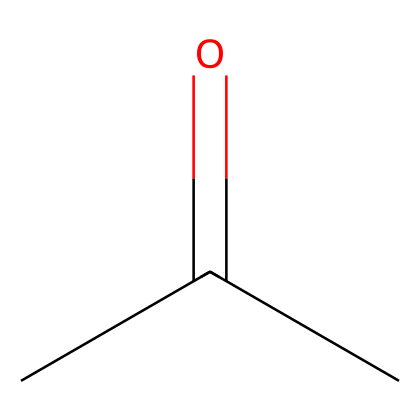What is the molecular formula of this compound? The SMILES notation CC(=O)C indicates that there are three carbon atoms, six hydrogen atoms, and one oxygen atom in the molecule, leading to the molecular formula C3H6O.
Answer: C3H6O How many carbon atoms are present in this molecule? Looking at the SMILES representation, there are three occurrences of 'C', indicating that there are three carbon atoms present in the structure.
Answer: 3 What type of functional group is present in this compound? The "=O" part in the SMILES indicates the presence of a carbonyl group, and since it's attached to a carbon (C) indicated by "CC(=O)", this is characteristic of a ketone.
Answer: ketone What is one common use of acetone? Acetone is commonly used as a solvent in various industrial applications, particularly for cleaning electronic components due to its ability to dissolve many substances.
Answer: solvent How many hydrogen atoms are bonded to the central carbon atom? In the SMILES CC(=O)C, the central carbon atom (the one bonded to the oxygen) has only one hydrogen atom attached to it, as it is also bonded to another carbon and an oxygen atom.
Answer: 1 What is the bond type between the carbon and oxygen in the carbonyl group? The bond type between the carbon and oxygen in the carbonyl group (as seen in the C=O notation) is a double bond, characterized by the "=" sign in the SMILES representation.
Answer: double bond 